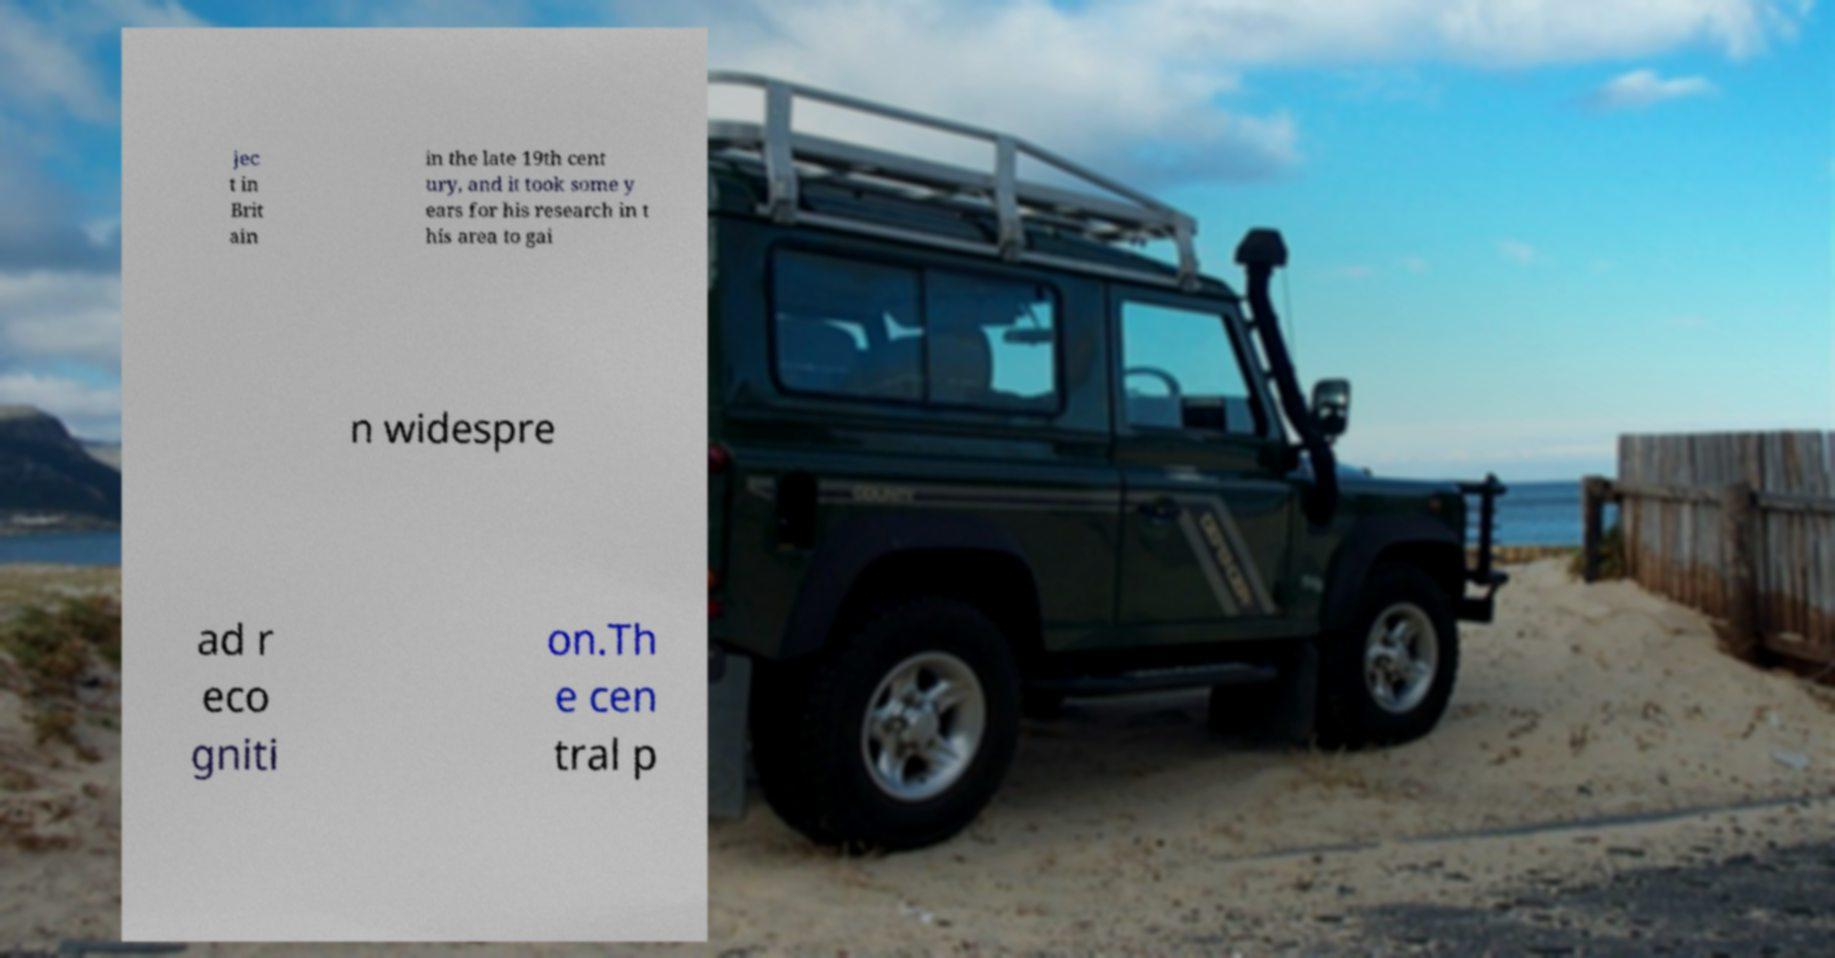Please identify and transcribe the text found in this image. jec t in Brit ain in the late 19th cent ury, and it took some y ears for his research in t his area to gai n widespre ad r eco gniti on.Th e cen tral p 